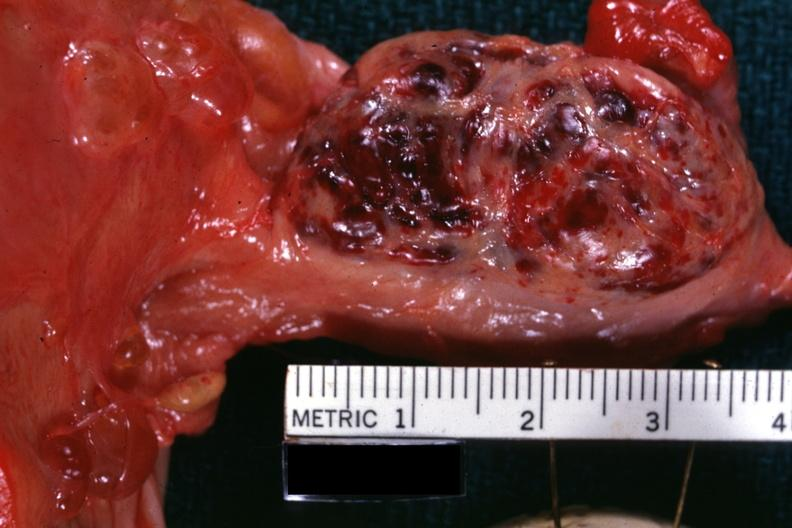s ovary present?
Answer the question using a single word or phrase. Yes 